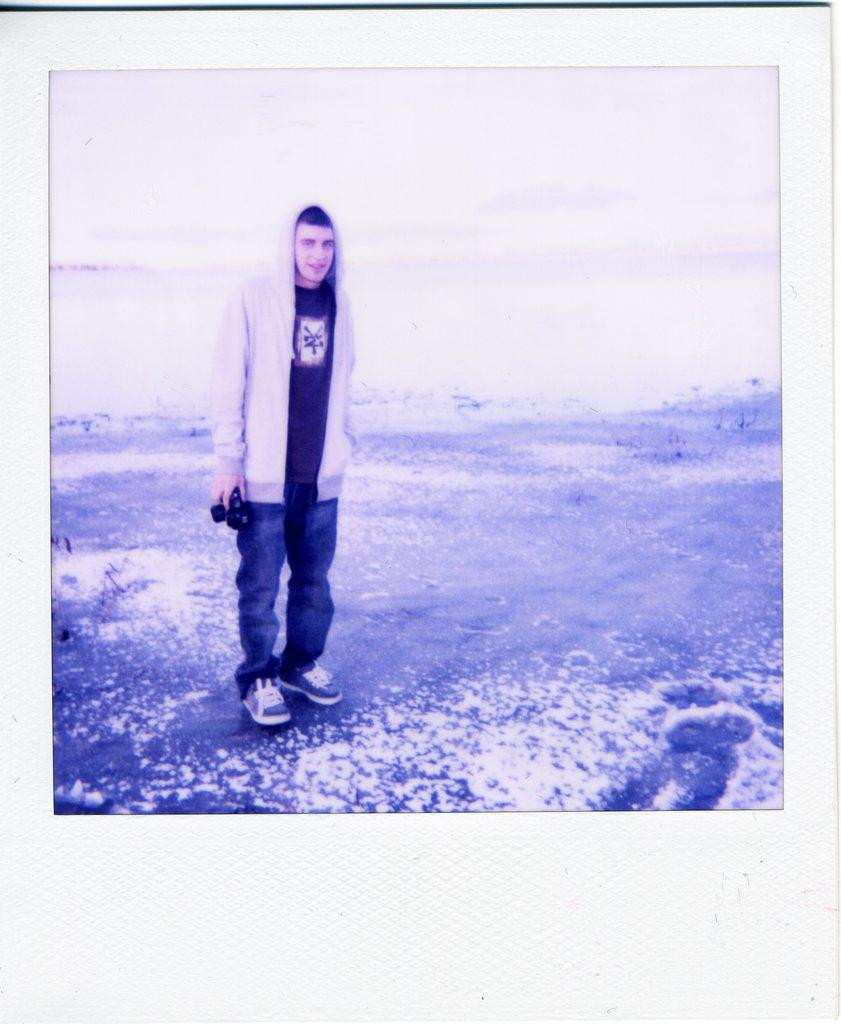What is the main subject of the image? There is a person in the image. What is the person doing in the image? The person is standing. What object is the person holding in the image? The person is holding a camera in his hand. What type of beef is the person holding in the image? There is no beef present in the image; the person is holding a camera. How many hands does the farmer have in the image? There is no farmer present in the image, and therefore no hands to count. 